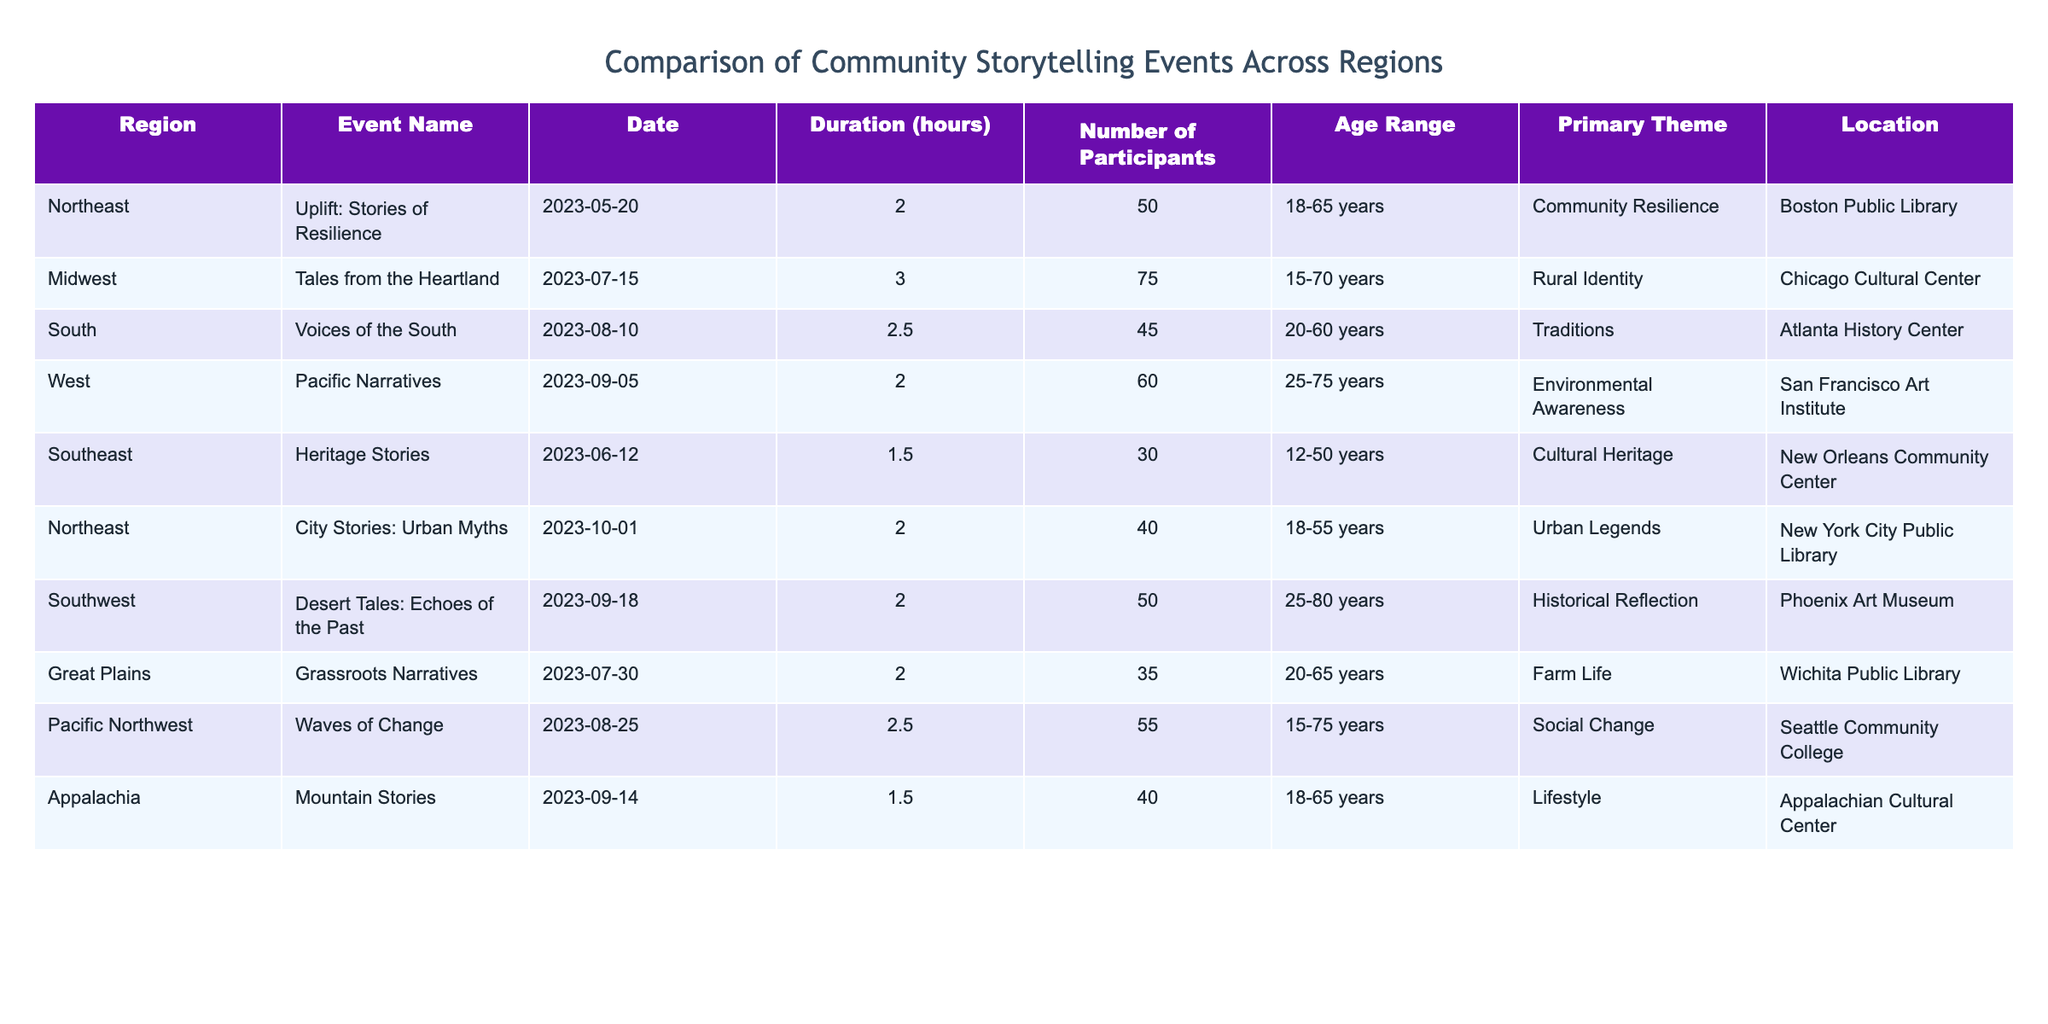What is the primary theme of the event held in the Southeast region? The Southeast region event is "Heritage Stories," which has its primary theme listed as "Cultural Heritage."
Answer: Cultural Heritage How many participants attended the "Tales from the Heartland" event? The event "Tales from the Heartland" is listed under the Midwest region, with the number of participants recorded as 75.
Answer: 75 Which region has the highest average duration of storytelling events? Calculating the average duration involves summing the durations from all regions: (2 + 3 + 2.5 + 2 + 1.5 + 2 + 2 + 2.5 + 1.5) = 20 and dividing by the number of events (9): 20 / 9 ≈ 2.22 hours. The regions have event durations close to this average: Midwest (3) is the highest.
Answer: Midwest Is the age range of participants the same for any two events? Checking the "Age Range" column for similarities, the events "Uplift: Stories of Resilience" and "Mountain Stories" both include the age range "18-65," indicating they share this participant demographic.
Answer: Yes How many storytelling events took place in the South region, and what are their primary themes? There are two events in the South region: "Voices of the South" with a primary theme of "Traditions," and "Desert Tales: Echoes of the Past," focusing on "Historical Reflection." This brings the total to two events with their respective themes.
Answer: 2 events: Traditions, Historical Reflection Which region had the lowest number of participants, and what was the event name? The "Grassroots Narratives" event in the Great Plains region had 35 participants, which is the lowest number recorded compared to the other events.
Answer: Great Plains, Grassroots Narratives What is the total number of participants across all events held in the West and Southwest regions? Adding the participants from the West (60 from "Pacific Narratives") and the Southwest (50 from "Desert Tales: Echoes of the Past") gives a total of 60 + 50 = 110 participants.
Answer: 110 participants Which event had the longest duration, and in which region did it occur? The event with the longest duration is "Tales from the Heartland" lasting 3 hours, which took place in the Midwest region, marking it as the longest duration for storytelling events.
Answer: Tales from the Heartland, Midwest Are there any events in the Northeast region that focus on urban themes? Checking the "Primary Theme" column for events in the Northeast, the event "City Stories: Urban Myths" explicitly mentions an urban theme, confirming it fits this criterion.
Answer: Yes 